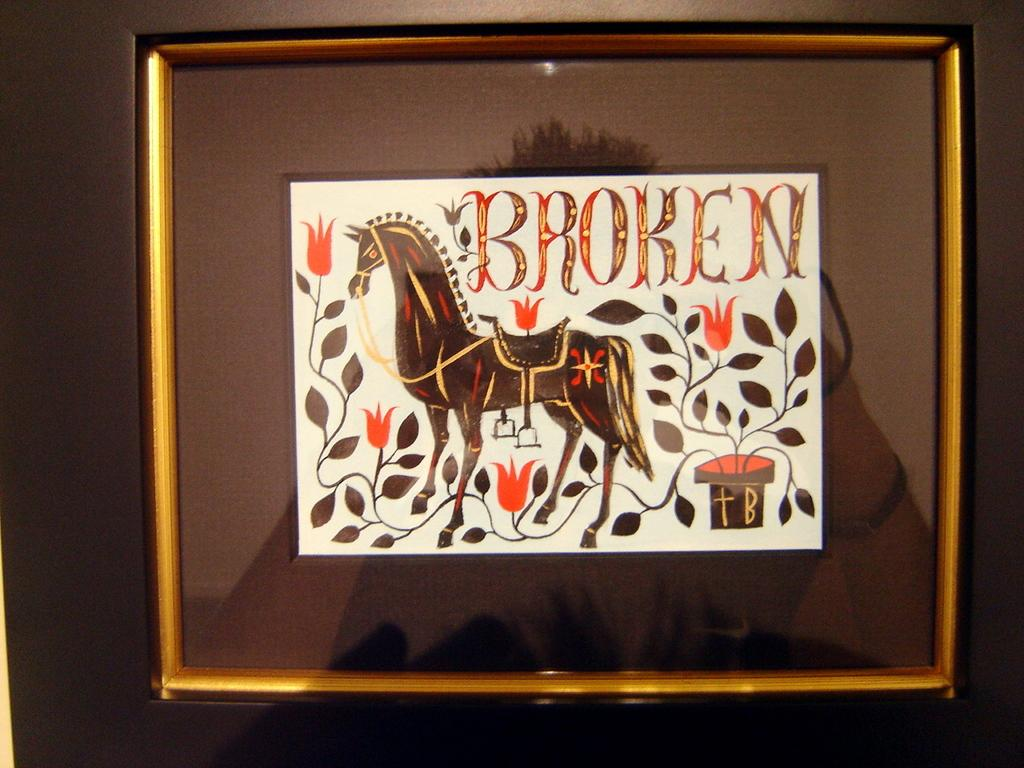What is the primary color of the object in the image? The primary color of the object in the image is white. What is featured on the white object? There is a painting on the white object, which depicts a horse and leaves. Is there any text present on the white object? Yes, there is text written on the white object. How many quarters can be seen in the image? There are no quarters present in the image. Can you describe the yak in the image? There is no yak present in the image; the painting depicts a horse and leaves. 